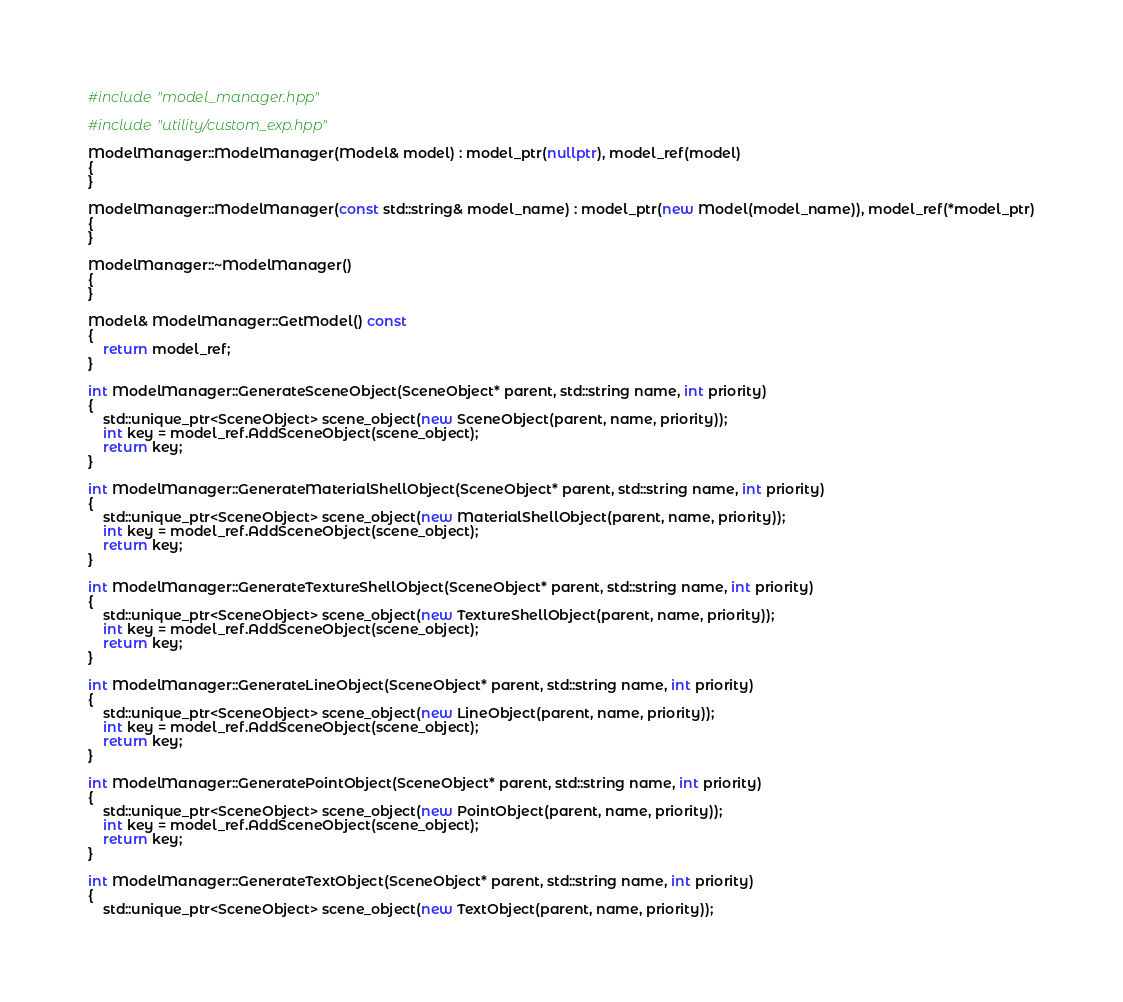Convert code to text. <code><loc_0><loc_0><loc_500><loc_500><_C++_>#include "model_manager.hpp"

#include "utility/custom_exp.hpp"

ModelManager::ModelManager(Model& model) : model_ptr(nullptr), model_ref(model)
{
}

ModelManager::ModelManager(const std::string& model_name) : model_ptr(new Model(model_name)), model_ref(*model_ptr)
{
}

ModelManager::~ModelManager()
{
}

Model& ModelManager::GetModel() const
{
    return model_ref;
}

int ModelManager::GenerateSceneObject(SceneObject* parent, std::string name, int priority)
{
    std::unique_ptr<SceneObject> scene_object(new SceneObject(parent, name, priority));
    int key = model_ref.AddSceneObject(scene_object);
    return key;
}

int ModelManager::GenerateMaterialShellObject(SceneObject* parent, std::string name, int priority)
{
    std::unique_ptr<SceneObject> scene_object(new MaterialShellObject(parent, name, priority));
    int key = model_ref.AddSceneObject(scene_object);
    return key;
}

int ModelManager::GenerateTextureShellObject(SceneObject* parent, std::string name, int priority)
{
    std::unique_ptr<SceneObject> scene_object(new TextureShellObject(parent, name, priority));
    int key = model_ref.AddSceneObject(scene_object);
    return key;
}

int ModelManager::GenerateLineObject(SceneObject* parent, std::string name, int priority)
{
    std::unique_ptr<SceneObject> scene_object(new LineObject(parent, name, priority));
    int key = model_ref.AddSceneObject(scene_object);
    return key;
}

int ModelManager::GeneratePointObject(SceneObject* parent, std::string name, int priority)
{
    std::unique_ptr<SceneObject> scene_object(new PointObject(parent, name, priority));
    int key = model_ref.AddSceneObject(scene_object);
    return key;
}

int ModelManager::GenerateTextObject(SceneObject* parent, std::string name, int priority)
{
    std::unique_ptr<SceneObject> scene_object(new TextObject(parent, name, priority));</code> 